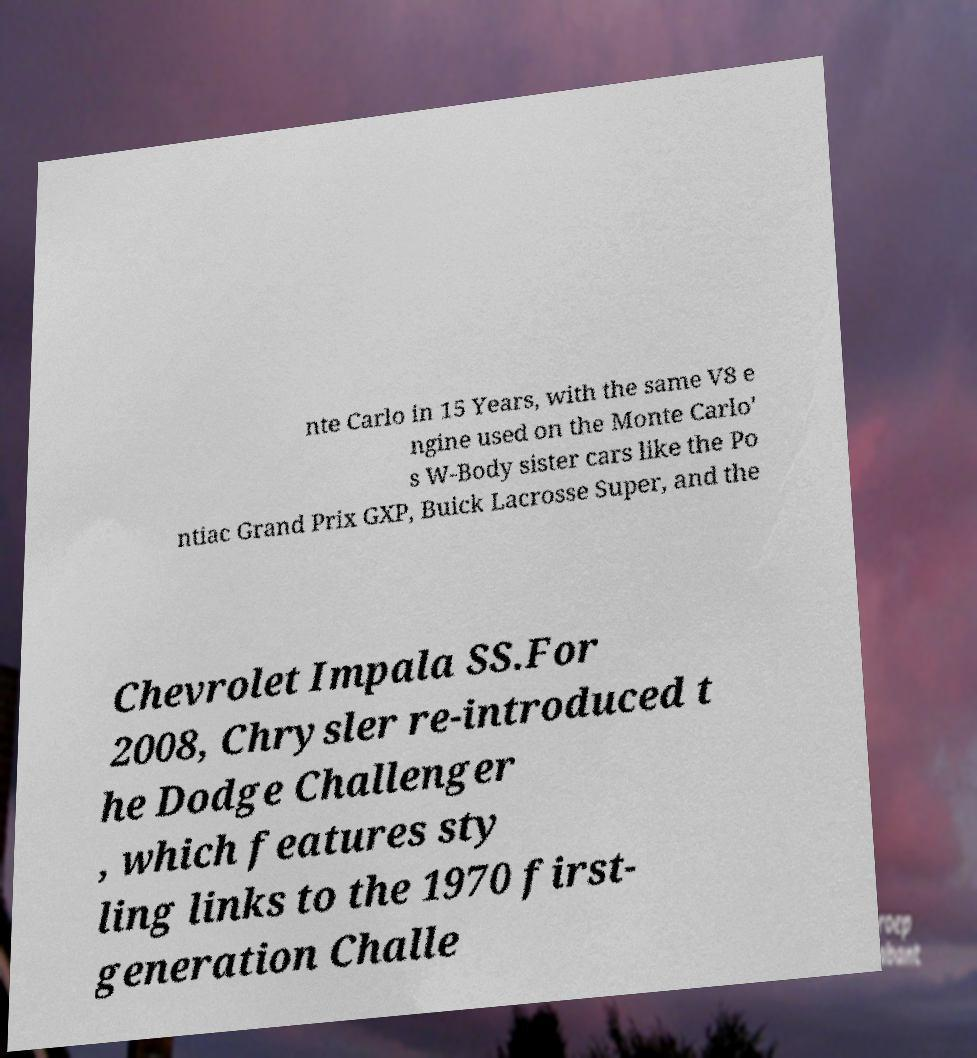Could you assist in decoding the text presented in this image and type it out clearly? nte Carlo in 15 Years, with the same V8 e ngine used on the Monte Carlo' s W-Body sister cars like the Po ntiac Grand Prix GXP, Buick Lacrosse Super, and the Chevrolet Impala SS.For 2008, Chrysler re-introduced t he Dodge Challenger , which features sty ling links to the 1970 first- generation Challe 